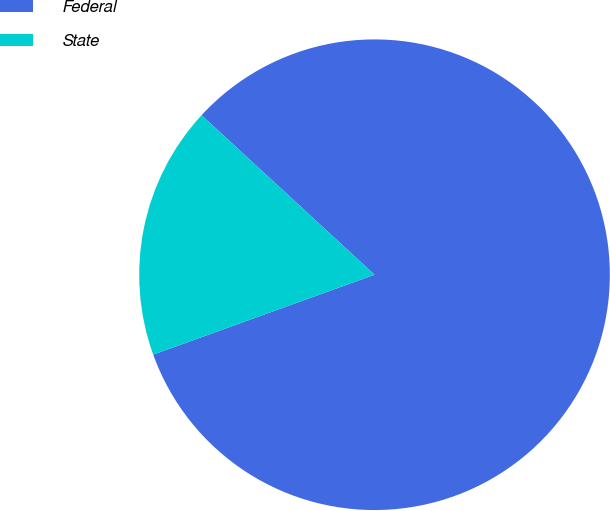Convert chart to OTSL. <chart><loc_0><loc_0><loc_500><loc_500><pie_chart><fcel>Federal<fcel>State<nl><fcel>82.63%<fcel>17.37%<nl></chart> 